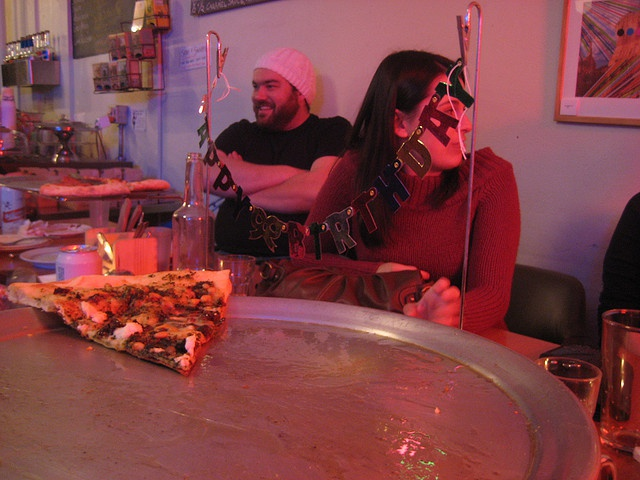Describe the objects in this image and their specific colors. I can see dining table in purple and brown tones, people in purple, maroon, black, and brown tones, people in purple, black, brown, and maroon tones, pizza in purple, maroon, brown, salmon, and red tones, and handbag in purple, maroon, black, and brown tones in this image. 